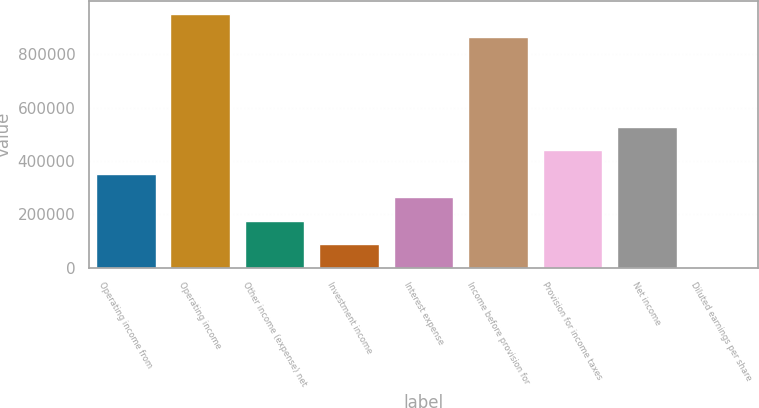Convert chart to OTSL. <chart><loc_0><loc_0><loc_500><loc_500><bar_chart><fcel>Operating income from<fcel>Operating income<fcel>Other income (expense) net<fcel>Investment income<fcel>Interest expense<fcel>Income before provision for<fcel>Provision for income taxes<fcel>Net income<fcel>Diluted earnings per share<nl><fcel>352834<fcel>952047<fcel>176419<fcel>88210.8<fcel>264626<fcel>863839<fcel>441042<fcel>529250<fcel>3.02<nl></chart> 